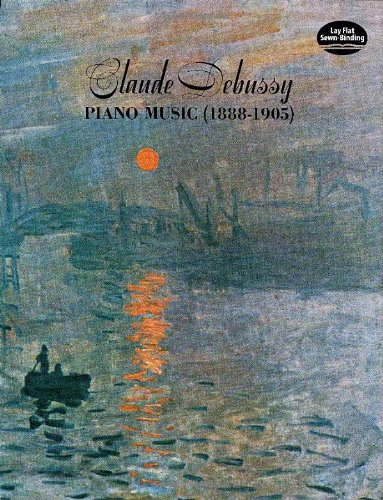What period does the cover art of this book evoke? The cover art of the book evokes the Impressionist period, notable for its use of light and color to capture moments in time, much like the essence captured in Debussy's music. 